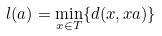Convert formula to latex. <formula><loc_0><loc_0><loc_500><loc_500>l ( a ) = \min _ { x \in T } \{ d ( x , x a ) \}</formula> 